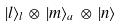Convert formula to latex. <formula><loc_0><loc_0><loc_500><loc_500>| l \rangle _ { l } \, \otimes \, | m \rangle _ { a } \, \otimes \, | n \rangle</formula> 